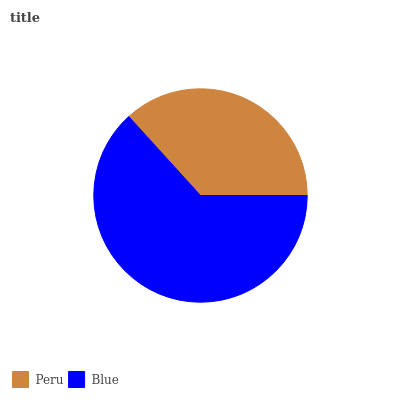Is Peru the minimum?
Answer yes or no. Yes. Is Blue the maximum?
Answer yes or no. Yes. Is Blue the minimum?
Answer yes or no. No. Is Blue greater than Peru?
Answer yes or no. Yes. Is Peru less than Blue?
Answer yes or no. Yes. Is Peru greater than Blue?
Answer yes or no. No. Is Blue less than Peru?
Answer yes or no. No. Is Blue the high median?
Answer yes or no. Yes. Is Peru the low median?
Answer yes or no. Yes. Is Peru the high median?
Answer yes or no. No. Is Blue the low median?
Answer yes or no. No. 